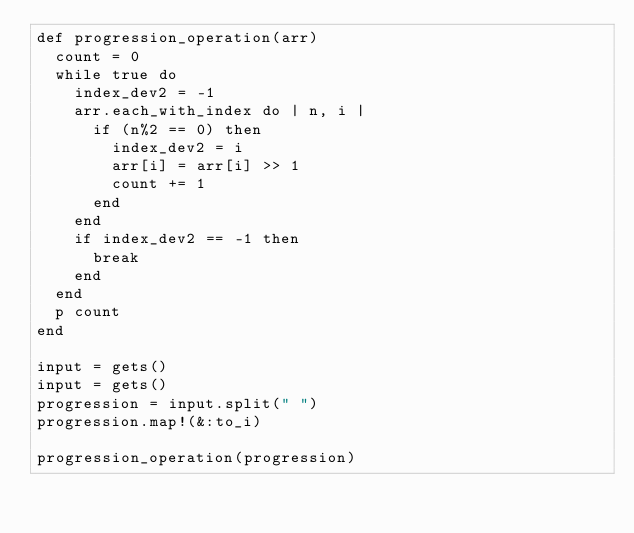<code> <loc_0><loc_0><loc_500><loc_500><_Ruby_>def progression_operation(arr)
  count = 0
  while true do
    index_dev2 = -1
    arr.each_with_index do | n, i |
      if (n%2 == 0) then
        index_dev2 = i
        arr[i] = arr[i] >> 1
        count += 1
      end
    end
    if index_dev2 == -1 then
      break
    end
  end
  p count
end

input = gets()
input = gets()
progression = input.split(" ")
progression.map!(&:to_i)

progression_operation(progression)
</code> 